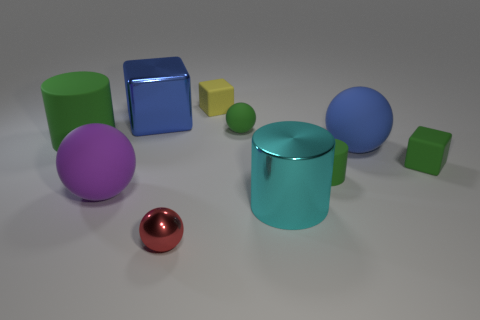Are there the same number of tiny green cylinders left of the big purple rubber ball and cylinders behind the large cyan metal thing?
Provide a short and direct response. No. Does the matte cube to the left of the green sphere have the same color as the rubber cylinder right of the purple object?
Give a very brief answer. No. Is the number of small rubber things in front of the blue cube greater than the number of matte blocks?
Your answer should be very brief. Yes. There is a tiny red thing that is made of the same material as the large cyan cylinder; what is its shape?
Your answer should be compact. Sphere. There is a green thing in front of the green rubber block; is it the same size as the purple matte sphere?
Your response must be concise. No. There is a big metallic thing in front of the green cylinder behind the tiny green rubber block; what is its shape?
Give a very brief answer. Cylinder. How big is the matte cube behind the green rubber cylinder that is on the left side of the large cyan shiny cylinder?
Provide a short and direct response. Small. The rubber cylinder on the left side of the yellow matte cube is what color?
Keep it short and to the point. Green. There is a blue object that is made of the same material as the purple ball; what size is it?
Offer a very short reply. Large. What number of other things have the same shape as the cyan thing?
Provide a succinct answer. 2. 